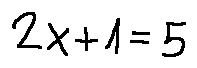Convert formula to latex. <formula><loc_0><loc_0><loc_500><loc_500>2 x + 1 = 5</formula> 